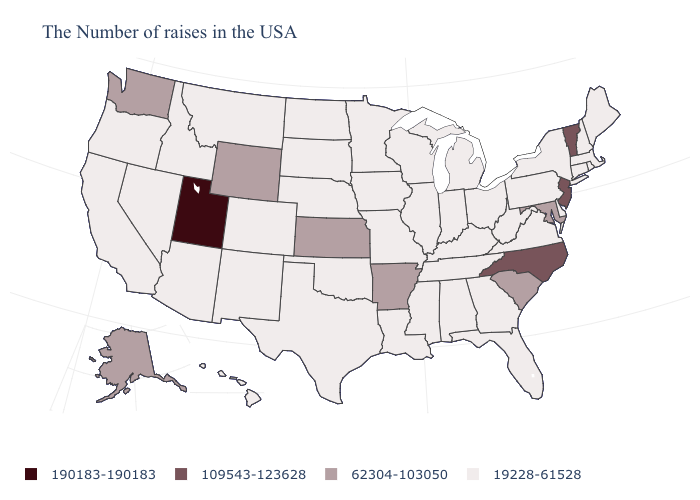What is the value of Massachusetts?
Write a very short answer. 19228-61528. What is the value of Iowa?
Short answer required. 19228-61528. Does Montana have the lowest value in the West?
Quick response, please. Yes. What is the value of South Carolina?
Be succinct. 62304-103050. Among the states that border South Dakota , which have the highest value?
Write a very short answer. Wyoming. Does the map have missing data?
Quick response, please. No. How many symbols are there in the legend?
Write a very short answer. 4. Does Utah have the highest value in the USA?
Answer briefly. Yes. Among the states that border Idaho , which have the lowest value?
Quick response, please. Montana, Nevada, Oregon. Does Kansas have the highest value in the MidWest?
Quick response, please. Yes. Which states hav the highest value in the West?
Quick response, please. Utah. Name the states that have a value in the range 19228-61528?
Keep it brief. Maine, Massachusetts, Rhode Island, New Hampshire, Connecticut, New York, Delaware, Pennsylvania, Virginia, West Virginia, Ohio, Florida, Georgia, Michigan, Kentucky, Indiana, Alabama, Tennessee, Wisconsin, Illinois, Mississippi, Louisiana, Missouri, Minnesota, Iowa, Nebraska, Oklahoma, Texas, South Dakota, North Dakota, Colorado, New Mexico, Montana, Arizona, Idaho, Nevada, California, Oregon, Hawaii. Among the states that border New Hampshire , which have the highest value?
Answer briefly. Vermont. Does the map have missing data?
Concise answer only. No. Name the states that have a value in the range 190183-190183?
Quick response, please. Utah. 